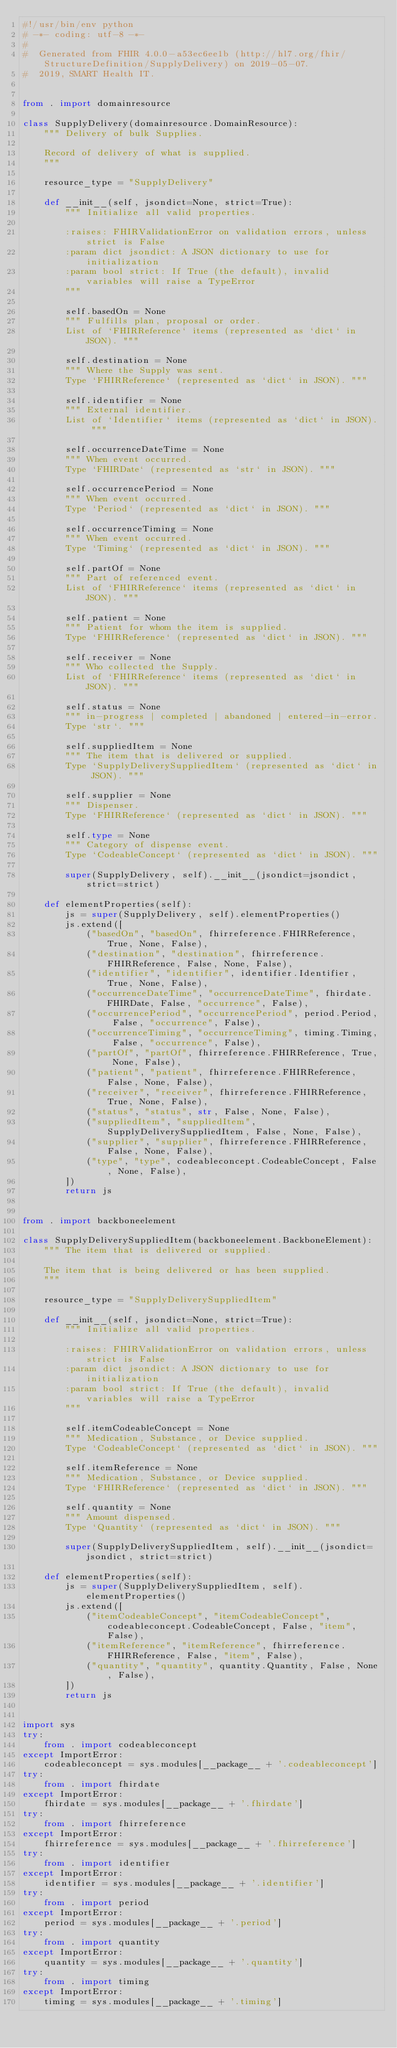<code> <loc_0><loc_0><loc_500><loc_500><_Python_>#!/usr/bin/env python
# -*- coding: utf-8 -*-
#
#  Generated from FHIR 4.0.0-a53ec6ee1b (http://hl7.org/fhir/StructureDefinition/SupplyDelivery) on 2019-05-07.
#  2019, SMART Health IT.


from . import domainresource

class SupplyDelivery(domainresource.DomainResource):
    """ Delivery of bulk Supplies.
    
    Record of delivery of what is supplied.
    """
    
    resource_type = "SupplyDelivery"
    
    def __init__(self, jsondict=None, strict=True):
        """ Initialize all valid properties.
        
        :raises: FHIRValidationError on validation errors, unless strict is False
        :param dict jsondict: A JSON dictionary to use for initialization
        :param bool strict: If True (the default), invalid variables will raise a TypeError
        """
        
        self.basedOn = None
        """ Fulfills plan, proposal or order.
        List of `FHIRReference` items (represented as `dict` in JSON). """
        
        self.destination = None
        """ Where the Supply was sent.
        Type `FHIRReference` (represented as `dict` in JSON). """
        
        self.identifier = None
        """ External identifier.
        List of `Identifier` items (represented as `dict` in JSON). """
        
        self.occurrenceDateTime = None
        """ When event occurred.
        Type `FHIRDate` (represented as `str` in JSON). """
        
        self.occurrencePeriod = None
        """ When event occurred.
        Type `Period` (represented as `dict` in JSON). """
        
        self.occurrenceTiming = None
        """ When event occurred.
        Type `Timing` (represented as `dict` in JSON). """
        
        self.partOf = None
        """ Part of referenced event.
        List of `FHIRReference` items (represented as `dict` in JSON). """
        
        self.patient = None
        """ Patient for whom the item is supplied.
        Type `FHIRReference` (represented as `dict` in JSON). """
        
        self.receiver = None
        """ Who collected the Supply.
        List of `FHIRReference` items (represented as `dict` in JSON). """
        
        self.status = None
        """ in-progress | completed | abandoned | entered-in-error.
        Type `str`. """
        
        self.suppliedItem = None
        """ The item that is delivered or supplied.
        Type `SupplyDeliverySuppliedItem` (represented as `dict` in JSON). """
        
        self.supplier = None
        """ Dispenser.
        Type `FHIRReference` (represented as `dict` in JSON). """
        
        self.type = None
        """ Category of dispense event.
        Type `CodeableConcept` (represented as `dict` in JSON). """
        
        super(SupplyDelivery, self).__init__(jsondict=jsondict, strict=strict)
    
    def elementProperties(self):
        js = super(SupplyDelivery, self).elementProperties()
        js.extend([
            ("basedOn", "basedOn", fhirreference.FHIRReference, True, None, False),
            ("destination", "destination", fhirreference.FHIRReference, False, None, False),
            ("identifier", "identifier", identifier.Identifier, True, None, False),
            ("occurrenceDateTime", "occurrenceDateTime", fhirdate.FHIRDate, False, "occurrence", False),
            ("occurrencePeriod", "occurrencePeriod", period.Period, False, "occurrence", False),
            ("occurrenceTiming", "occurrenceTiming", timing.Timing, False, "occurrence", False),
            ("partOf", "partOf", fhirreference.FHIRReference, True, None, False),
            ("patient", "patient", fhirreference.FHIRReference, False, None, False),
            ("receiver", "receiver", fhirreference.FHIRReference, True, None, False),
            ("status", "status", str, False, None, False),
            ("suppliedItem", "suppliedItem", SupplyDeliverySuppliedItem, False, None, False),
            ("supplier", "supplier", fhirreference.FHIRReference, False, None, False),
            ("type", "type", codeableconcept.CodeableConcept, False, None, False),
        ])
        return js


from . import backboneelement

class SupplyDeliverySuppliedItem(backboneelement.BackboneElement):
    """ The item that is delivered or supplied.
    
    The item that is being delivered or has been supplied.
    """
    
    resource_type = "SupplyDeliverySuppliedItem"
    
    def __init__(self, jsondict=None, strict=True):
        """ Initialize all valid properties.
        
        :raises: FHIRValidationError on validation errors, unless strict is False
        :param dict jsondict: A JSON dictionary to use for initialization
        :param bool strict: If True (the default), invalid variables will raise a TypeError
        """
        
        self.itemCodeableConcept = None
        """ Medication, Substance, or Device supplied.
        Type `CodeableConcept` (represented as `dict` in JSON). """
        
        self.itemReference = None
        """ Medication, Substance, or Device supplied.
        Type `FHIRReference` (represented as `dict` in JSON). """
        
        self.quantity = None
        """ Amount dispensed.
        Type `Quantity` (represented as `dict` in JSON). """
        
        super(SupplyDeliverySuppliedItem, self).__init__(jsondict=jsondict, strict=strict)
    
    def elementProperties(self):
        js = super(SupplyDeliverySuppliedItem, self).elementProperties()
        js.extend([
            ("itemCodeableConcept", "itemCodeableConcept", codeableconcept.CodeableConcept, False, "item", False),
            ("itemReference", "itemReference", fhirreference.FHIRReference, False, "item", False),
            ("quantity", "quantity", quantity.Quantity, False, None, False),
        ])
        return js


import sys
try:
    from . import codeableconcept
except ImportError:
    codeableconcept = sys.modules[__package__ + '.codeableconcept']
try:
    from . import fhirdate
except ImportError:
    fhirdate = sys.modules[__package__ + '.fhirdate']
try:
    from . import fhirreference
except ImportError:
    fhirreference = sys.modules[__package__ + '.fhirreference']
try:
    from . import identifier
except ImportError:
    identifier = sys.modules[__package__ + '.identifier']
try:
    from . import period
except ImportError:
    period = sys.modules[__package__ + '.period']
try:
    from . import quantity
except ImportError:
    quantity = sys.modules[__package__ + '.quantity']
try:
    from . import timing
except ImportError:
    timing = sys.modules[__package__ + '.timing']
</code> 